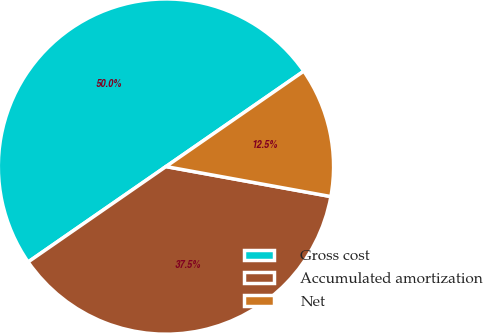Convert chart. <chart><loc_0><loc_0><loc_500><loc_500><pie_chart><fcel>Gross cost<fcel>Accumulated amortization<fcel>Net<nl><fcel>50.0%<fcel>37.5%<fcel>12.5%<nl></chart> 